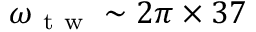<formula> <loc_0><loc_0><loc_500><loc_500>\omega _ { t w } \sim 2 \pi \times 3 7</formula> 